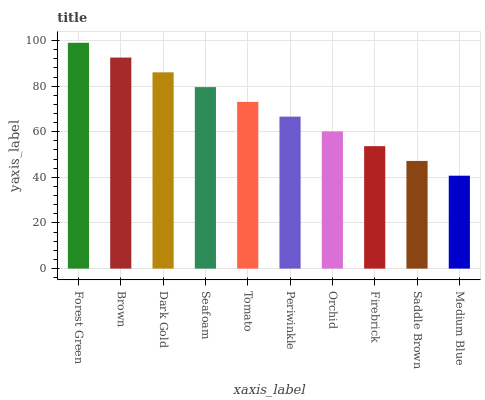Is Medium Blue the minimum?
Answer yes or no. Yes. Is Forest Green the maximum?
Answer yes or no. Yes. Is Brown the minimum?
Answer yes or no. No. Is Brown the maximum?
Answer yes or no. No. Is Forest Green greater than Brown?
Answer yes or no. Yes. Is Brown less than Forest Green?
Answer yes or no. Yes. Is Brown greater than Forest Green?
Answer yes or no. No. Is Forest Green less than Brown?
Answer yes or no. No. Is Tomato the high median?
Answer yes or no. Yes. Is Periwinkle the low median?
Answer yes or no. Yes. Is Orchid the high median?
Answer yes or no. No. Is Firebrick the low median?
Answer yes or no. No. 